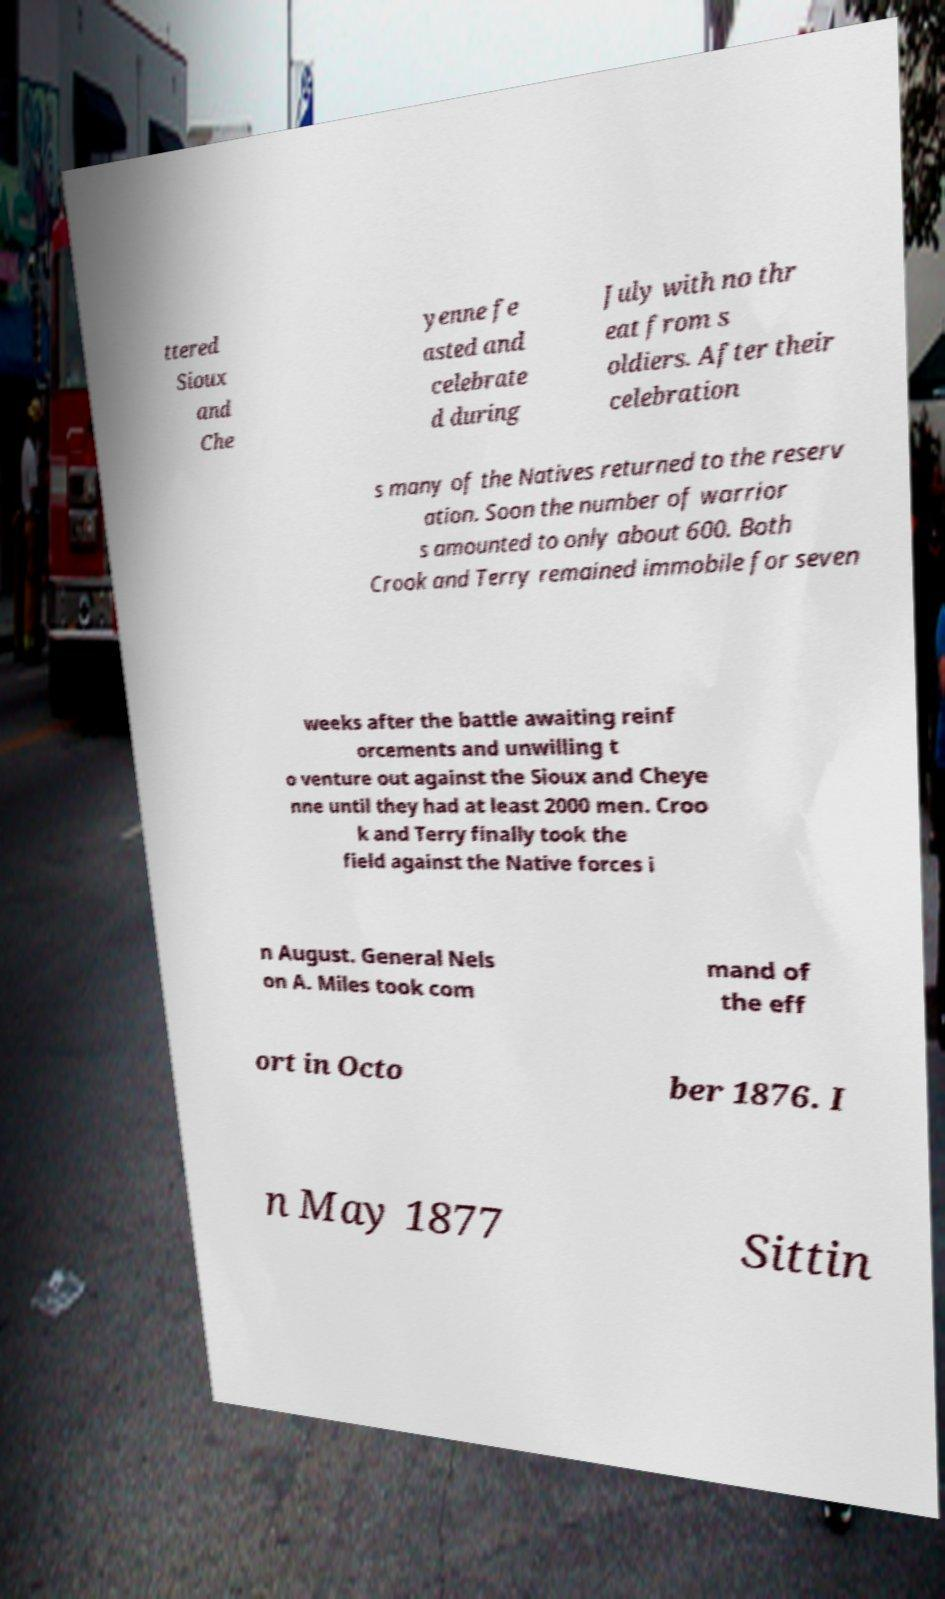Can you read and provide the text displayed in the image?This photo seems to have some interesting text. Can you extract and type it out for me? ttered Sioux and Che yenne fe asted and celebrate d during July with no thr eat from s oldiers. After their celebration s many of the Natives returned to the reserv ation. Soon the number of warrior s amounted to only about 600. Both Crook and Terry remained immobile for seven weeks after the battle awaiting reinf orcements and unwilling t o venture out against the Sioux and Cheye nne until they had at least 2000 men. Croo k and Terry finally took the field against the Native forces i n August. General Nels on A. Miles took com mand of the eff ort in Octo ber 1876. I n May 1877 Sittin 